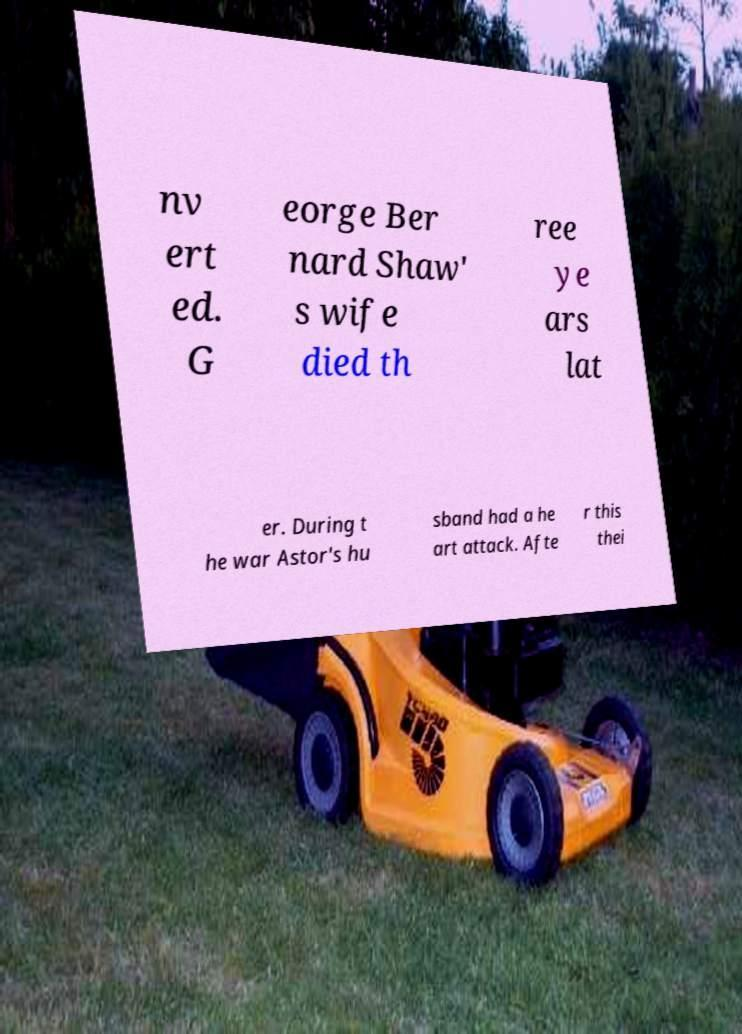Can you accurately transcribe the text from the provided image for me? nv ert ed. G eorge Ber nard Shaw' s wife died th ree ye ars lat er. During t he war Astor's hu sband had a he art attack. Afte r this thei 